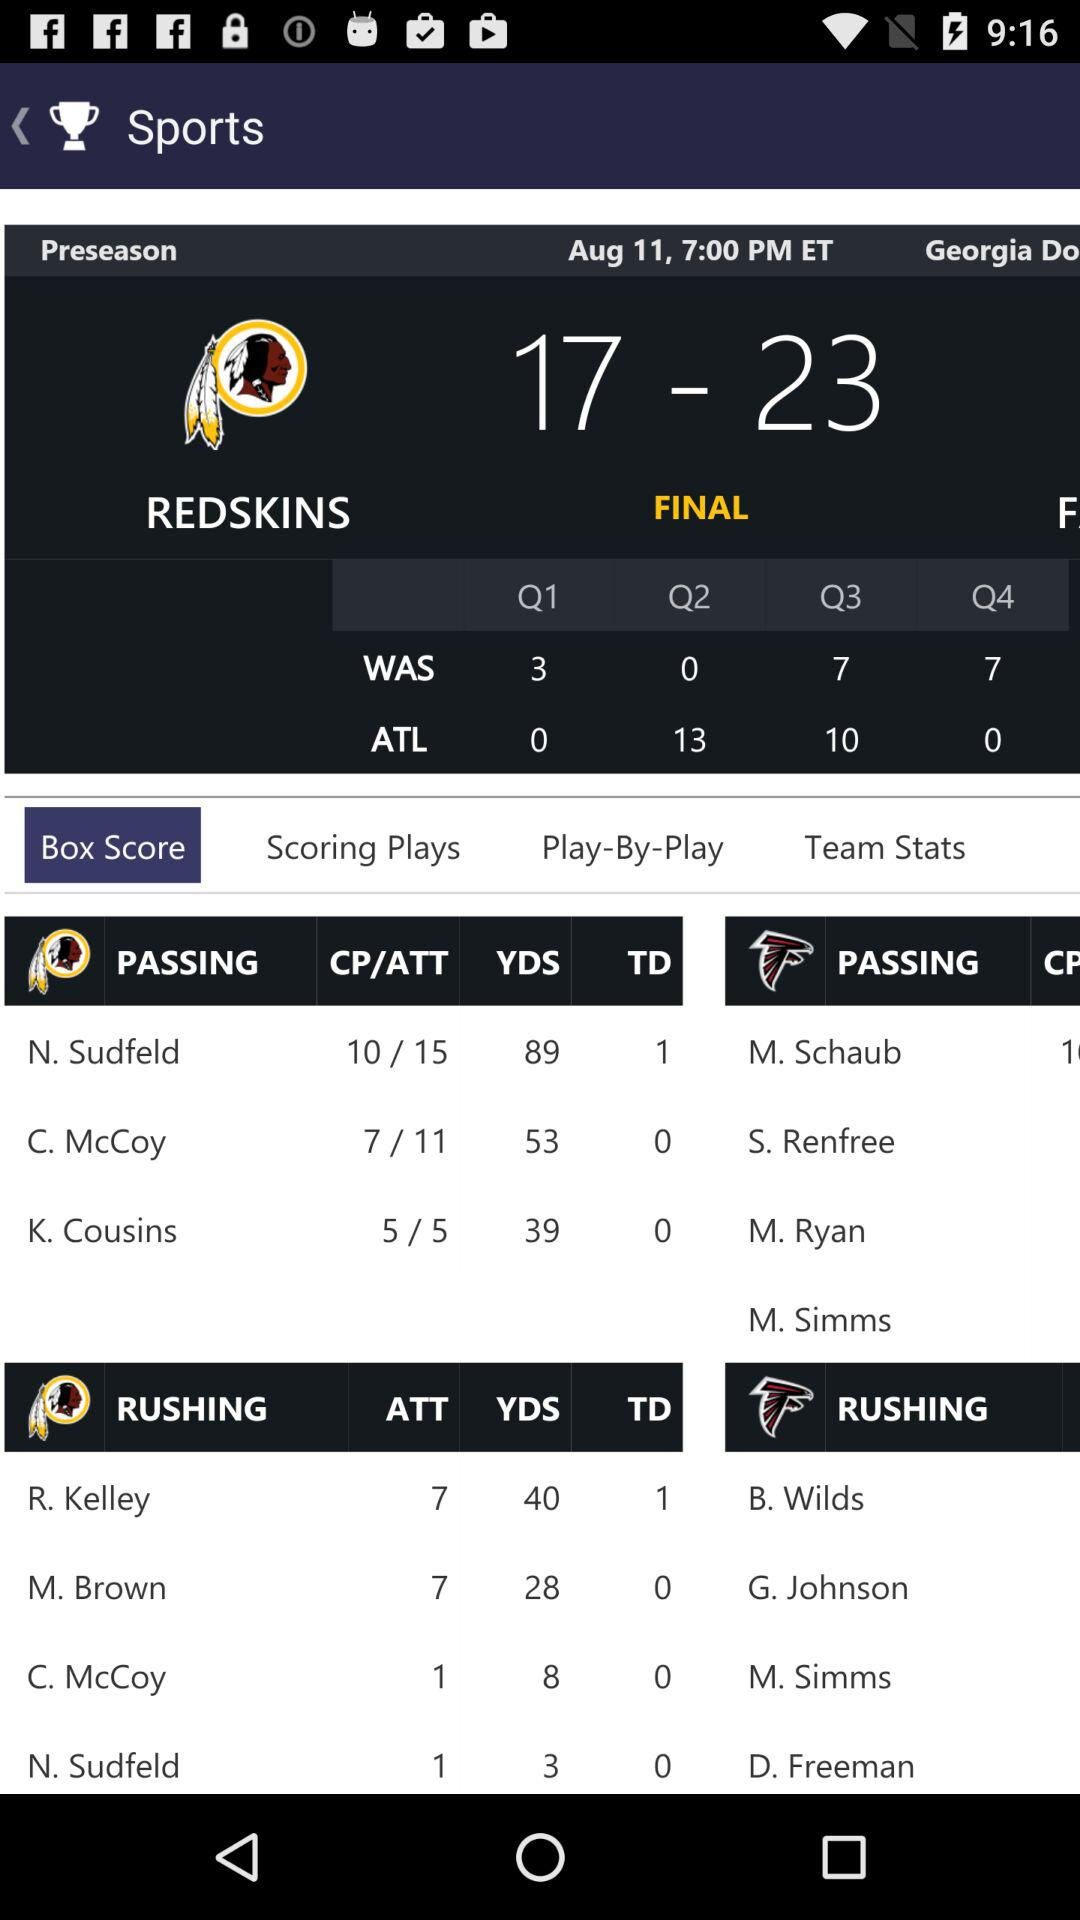What is the number of rushing yards for N. Sudfeld? The number of rushing yards for N. Sudfeld is 3. 